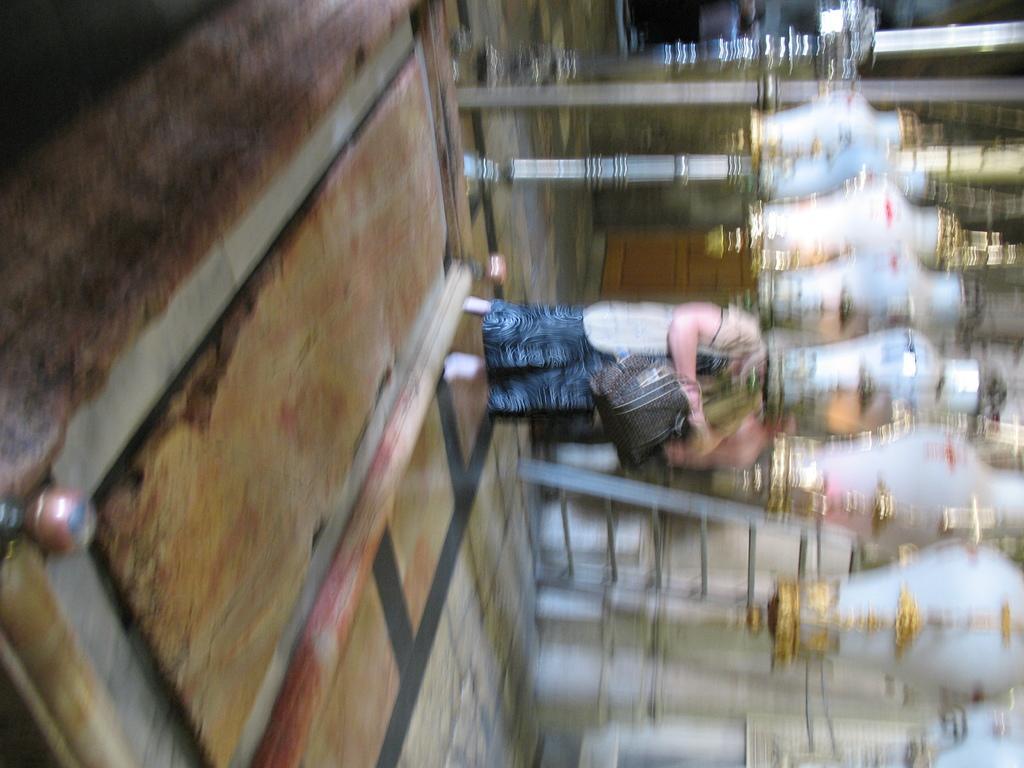How would you summarize this image in a sentence or two? The image is blurred. We can see a person standing. On the right side there are some white color objects. 